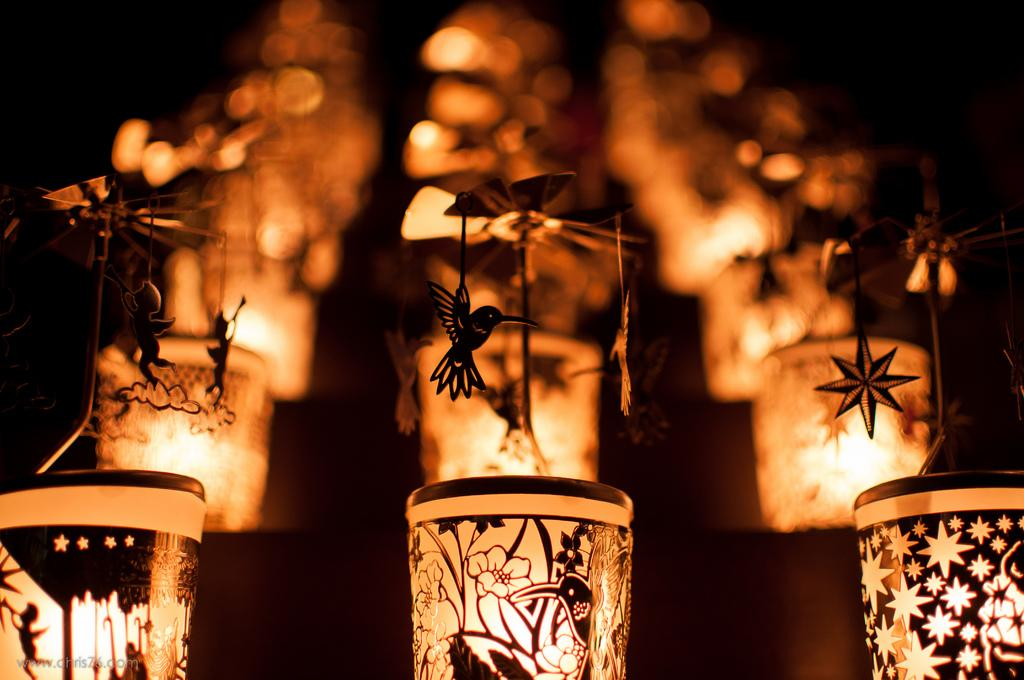What type of lighting is present in the image? There are lantern lamps in the image. Can you describe the appearance of the lantern lamps? The lantern lamps have a design. What can be observed about the background of the image? The background of the image is blurry. Can you tell me how many robins are perched on the lantern lamps in the image? There are no robins present in the image; it features lantern lamps with a design. What type of cannon is visible in the image? There is no cannon present in the image. 